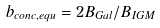Convert formula to latex. <formula><loc_0><loc_0><loc_500><loc_500>b _ { c o n c , e q u } = 2 B _ { G a l } / B _ { I G M }</formula> 